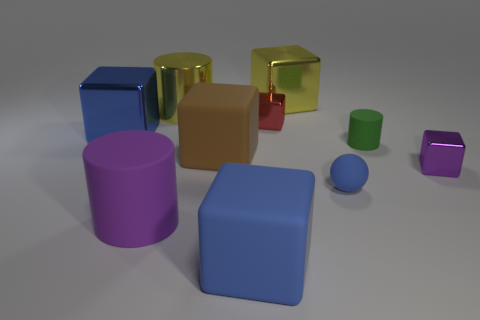Are there more small red shiny objects than big red rubber spheres?
Ensure brevity in your answer.  Yes. What is the small red cube made of?
Keep it short and to the point. Metal. What is the size of the blue shiny object that is the same shape as the small red object?
Keep it short and to the point. Large. Are there any shiny things to the left of the rubber cube to the right of the brown block?
Your response must be concise. Yes. How many other objects are there of the same shape as the small blue matte thing?
Provide a succinct answer. 0. Is the number of brown matte blocks that are right of the tiny green cylinder greater than the number of small objects behind the large blue metallic thing?
Your answer should be very brief. No. There is a metallic cylinder that is behind the large purple cylinder; is its size the same as the metallic block on the right side of the green cylinder?
Keep it short and to the point. No. The purple matte thing is what shape?
Your answer should be compact. Cylinder. What is the size of the cube that is the same color as the metallic cylinder?
Your answer should be compact. Large. The other small thing that is the same material as the small purple object is what color?
Keep it short and to the point. Red. 